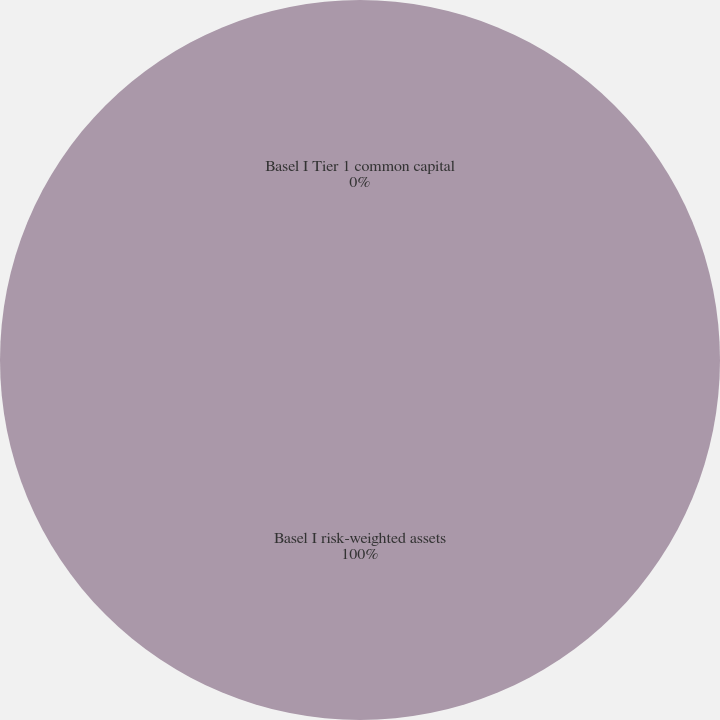Convert chart to OTSL. <chart><loc_0><loc_0><loc_500><loc_500><pie_chart><fcel>Basel I Tier 1 common capital<fcel>Basel I risk-weighted assets<nl><fcel>0.0%<fcel>100.0%<nl></chart> 